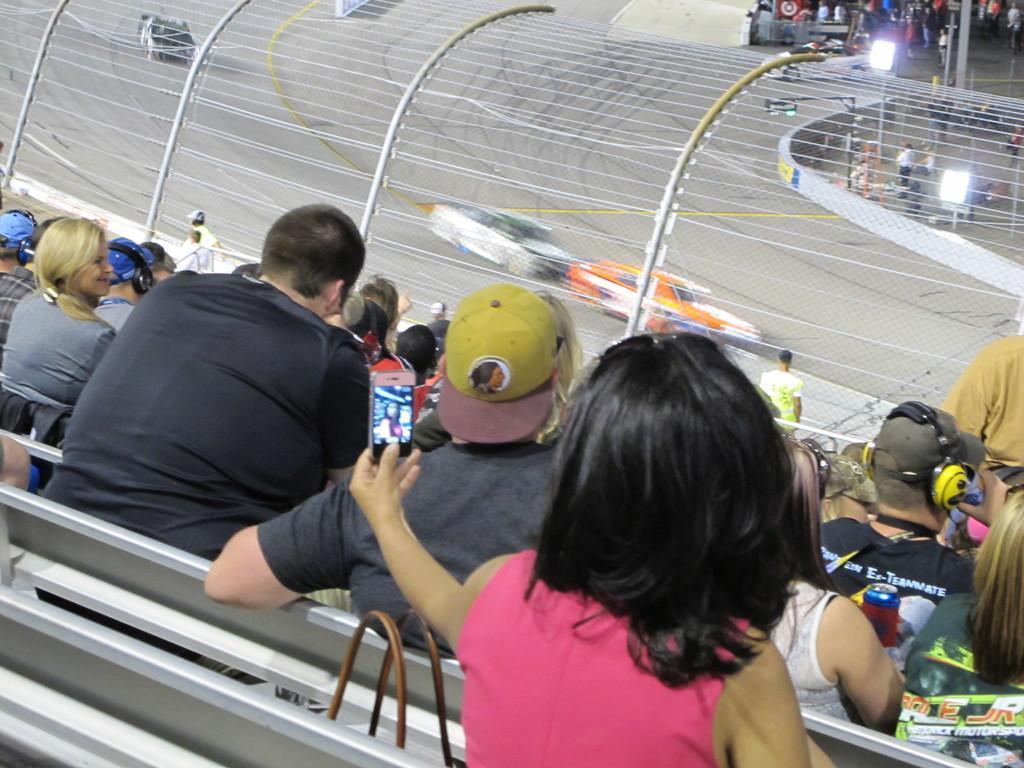Can you describe this image briefly? This image consists of a stadium in which there are many persons sitting. It looks like a car racing. At the bottom, there is a woman taking a selfie picture. 